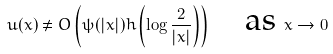Convert formula to latex. <formula><loc_0><loc_0><loc_500><loc_500>u ( x ) \neq O \left ( \psi ( | x | ) h \left ( \log \frac { 2 } { | x | } \right ) \right ) \quad \text {as } x \to 0</formula> 